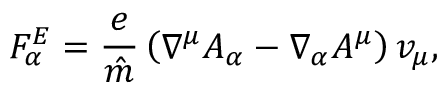Convert formula to latex. <formula><loc_0><loc_0><loc_500><loc_500>F _ { \alpha } ^ { E } = \frac { e } { \hat { m } } \left ( \nabla ^ { \mu } A _ { \alpha } - \nabla _ { \alpha } A ^ { \mu } \right ) v _ { \mu } ,</formula> 